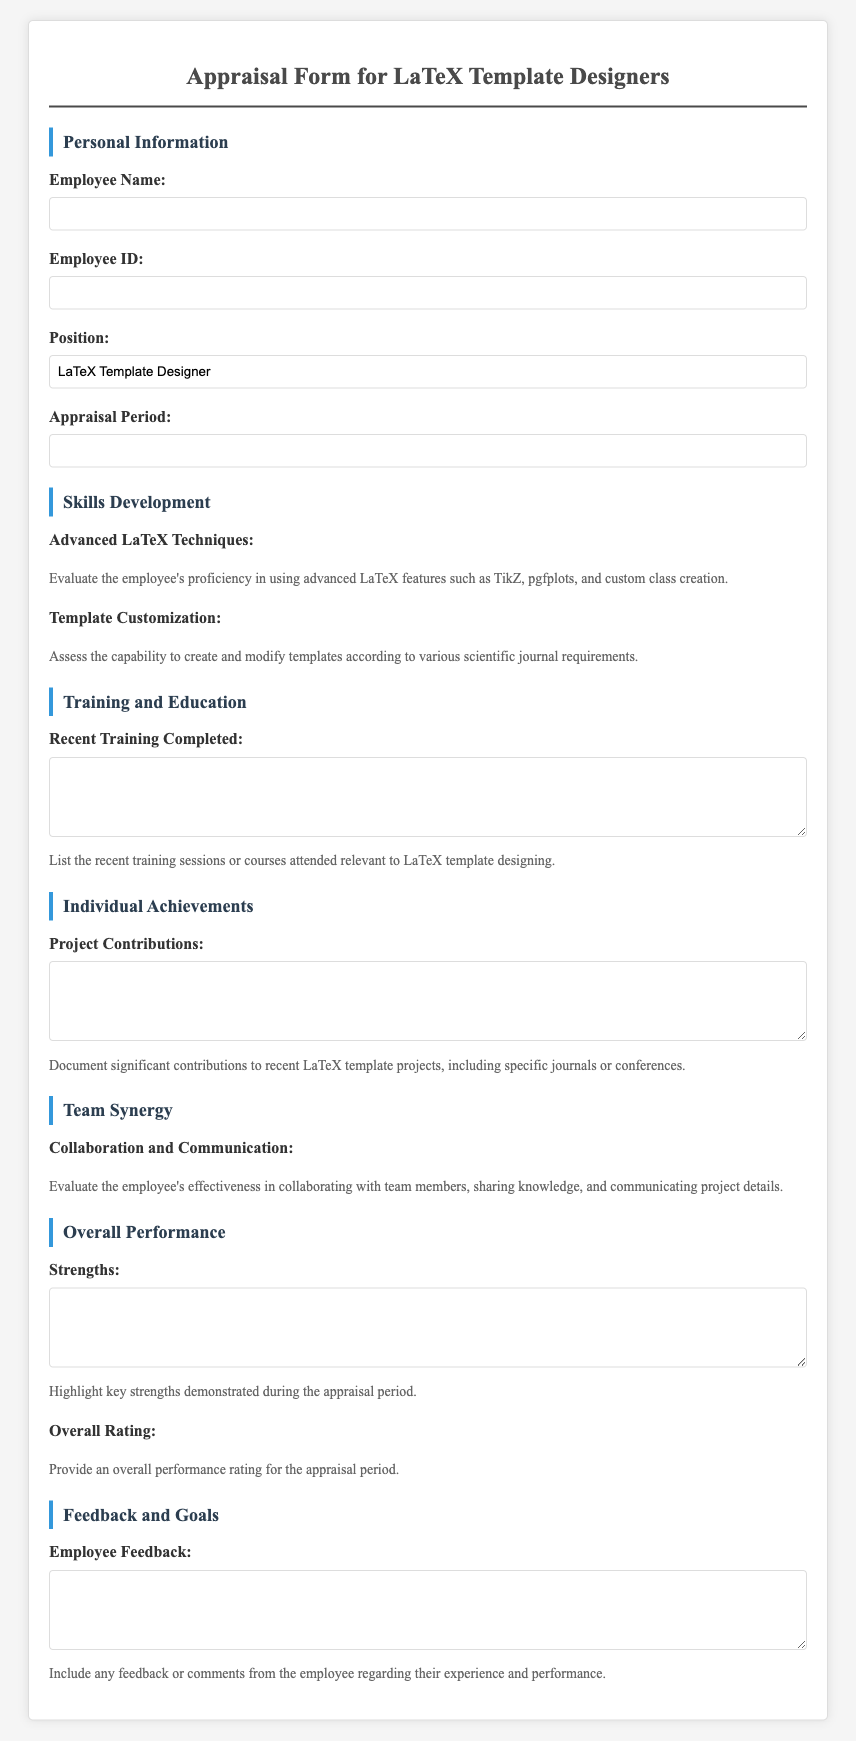What is the title of the document? The title of the document is the heading found at the top of the form.
Answer: Appraisal Form for LaTeX Template Designers What is the required position for this appraisal? The position is specified in the document under personal information.
Answer: LaTeX Template Designer What should be included in the recent training section? This section requires a detailed account of training sessions or courses attended by the employee.
Answer: Recent training sessions or courses attended relevant to LaTeX template designing How is the employee's collaboration evaluated? The document describes the evaluation method as a rating system under the "Team Synergy" section.
Answer: Rating (1 to 5 stars) What is asked for in the strengths section? This section invites the employee to highlight their key strengths demonstrated during the appraisal.
Answer: Key strengths demonstrated during the appraisal period What does the rating scale range from? The rating scale starts from the lowest score up to the highest score.
Answer: 1 to 5 What type of contributions are documented in the project contributions section? This section specifically requests significant contributions related to recent projects.
Answer: Significant contributions to recent LaTeX template projects What is the purpose of the employee feedback section? This section aims to gather comments or feedback from the employee about their experience.
Answer: Feedback or comments from the employee regarding their experience and performance 